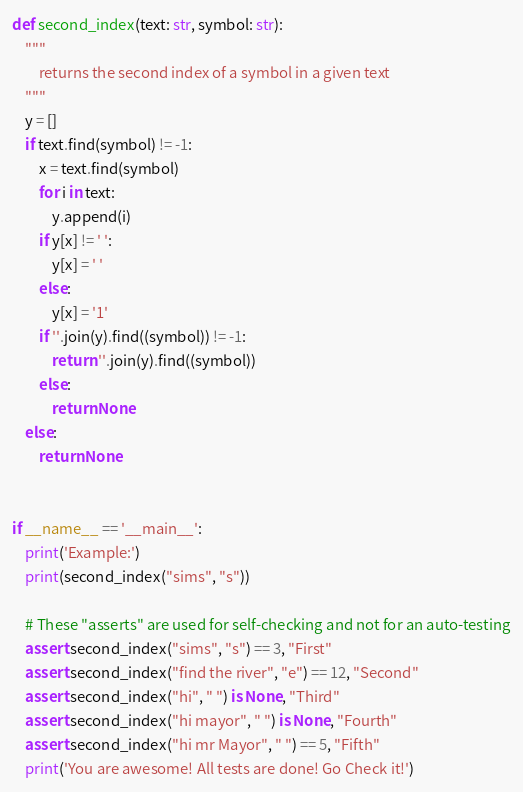Convert code to text. <code><loc_0><loc_0><loc_500><loc_500><_Python_>def second_index(text: str, symbol: str):
    """
        returns the second index of a symbol in a given text
    """
    y = []
    if text.find(symbol) != -1:
        x = text.find(symbol)
        for i in text:
            y.append(i)
        if y[x] != ' ':
            y[x] = ' '
        else:
            y[x] = '1'
        if ''.join(y).find((symbol)) != -1:
            return ''.join(y).find((symbol))
        else:
            return None
    else:
        return None


if __name__ == '__main__':
    print('Example:')
    print(second_index("sims", "s"))

    # These "asserts" are used for self-checking and not for an auto-testing
    assert second_index("sims", "s") == 3, "First"
    assert second_index("find the river", "e") == 12, "Second"
    assert second_index("hi", " ") is None, "Third"
    assert second_index("hi mayor", " ") is None, "Fourth"
    assert second_index("hi mr Mayor", " ") == 5, "Fifth"
    print('You are awesome! All tests are done! Go Check it!')
</code> 